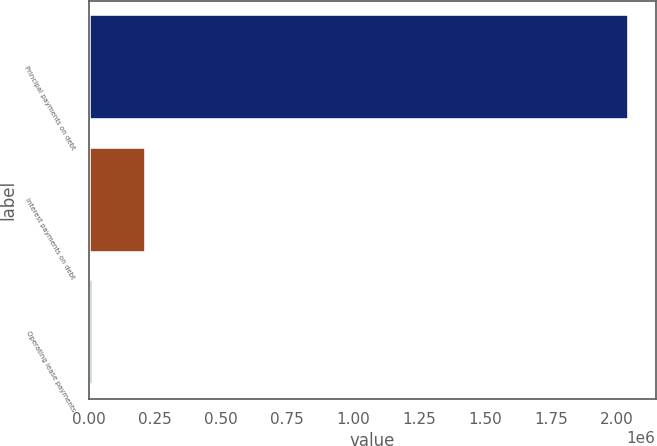Convert chart. <chart><loc_0><loc_0><loc_500><loc_500><bar_chart><fcel>Principal payments on debt<fcel>Interest payments on debt<fcel>Operating lease payments<nl><fcel>2.045e+06<fcel>216854<fcel>13727<nl></chart> 